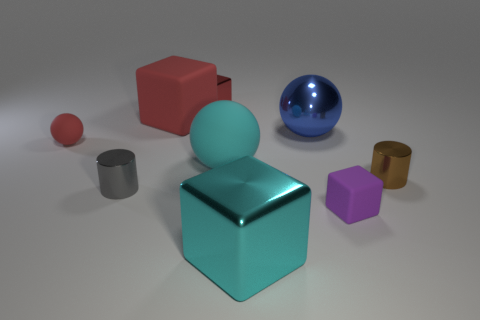Subtract all rubber spheres. How many spheres are left? 1 Subtract all blue cubes. Subtract all green cylinders. How many cubes are left? 4 Subtract all spheres. How many objects are left? 6 Subtract 0 yellow spheres. How many objects are left? 9 Subtract all cylinders. Subtract all red matte blocks. How many objects are left? 6 Add 9 big red matte objects. How many big red matte objects are left? 10 Add 8 tiny metallic blocks. How many tiny metallic blocks exist? 9 